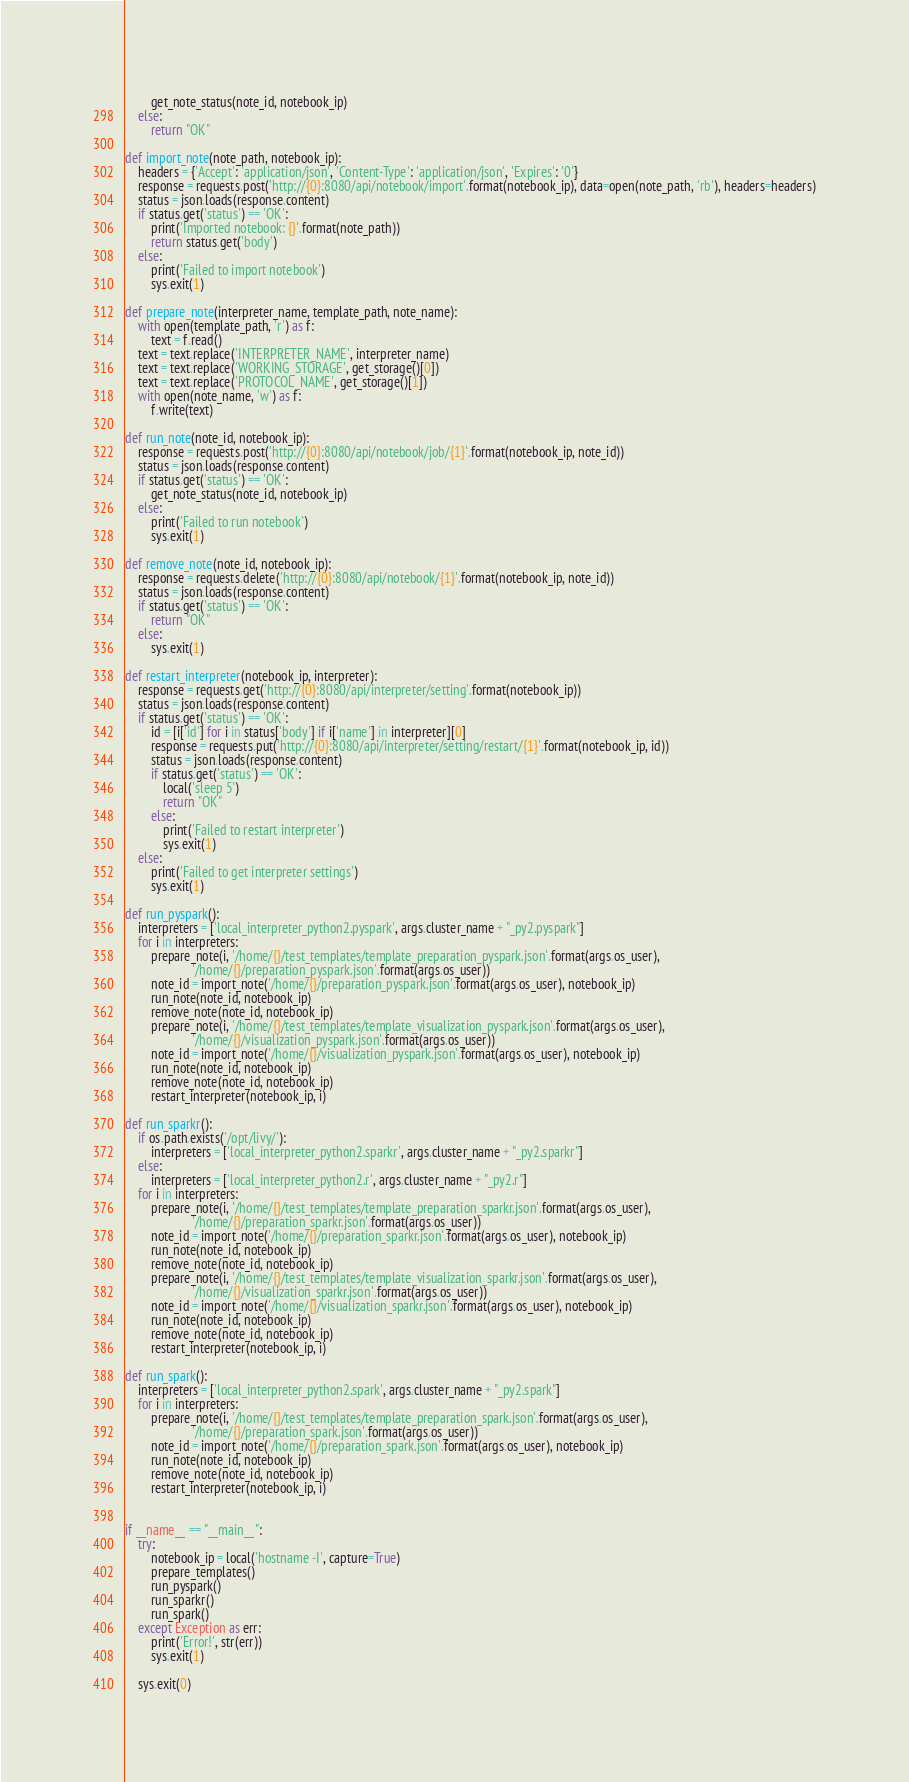Convert code to text. <code><loc_0><loc_0><loc_500><loc_500><_Python_>        get_note_status(note_id, notebook_ip)
    else:
        return "OK"

def import_note(note_path, notebook_ip):
    headers = {'Accept': 'application/json', 'Content-Type': 'application/json', 'Expires': '0'}
    response = requests.post('http://{0}:8080/api/notebook/import'.format(notebook_ip), data=open(note_path, 'rb'), headers=headers)
    status = json.loads(response.content)
    if status.get('status') == 'OK':
        print('Imported notebook: {}'.format(note_path))
        return status.get('body')
    else:
        print('Failed to import notebook')
        sys.exit(1)

def prepare_note(interpreter_name, template_path, note_name):
    with open(template_path, 'r') as f:
        text = f.read()
    text = text.replace('INTERPRETER_NAME', interpreter_name)
    text = text.replace('WORKING_STORAGE', get_storage()[0])
    text = text.replace('PROTOCOL_NAME', get_storage()[1])
    with open(note_name, 'w') as f:
        f.write(text)

def run_note(note_id, notebook_ip):
    response = requests.post('http://{0}:8080/api/notebook/job/{1}'.format(notebook_ip, note_id))
    status = json.loads(response.content)
    if status.get('status') == 'OK':
        get_note_status(note_id, notebook_ip)
    else:
        print('Failed to run notebook')
        sys.exit(1)

def remove_note(note_id, notebook_ip):
    response = requests.delete('http://{0}:8080/api/notebook/{1}'.format(notebook_ip, note_id))
    status = json.loads(response.content)
    if status.get('status') == 'OK':
        return "OK"
    else:
        sys.exit(1)

def restart_interpreter(notebook_ip, interpreter):
    response = requests.get('http://{0}:8080/api/interpreter/setting'.format(notebook_ip))
    status = json.loads(response.content)
    if status.get('status') == 'OK':
        id = [i['id'] for i in status['body'] if i['name'] in interpreter][0]
        response = requests.put('http://{0}:8080/api/interpreter/setting/restart/{1}'.format(notebook_ip, id))
        status = json.loads(response.content)
        if status.get('status') == 'OK':
            local('sleep 5')
            return "OK"
        else:
            print('Failed to restart interpreter')
            sys.exit(1)
    else:
        print('Failed to get interpreter settings')
        sys.exit(1)

def run_pyspark():
    interpreters = ['local_interpreter_python2.pyspark', args.cluster_name + "_py2.pyspark"]
    for i in interpreters:
        prepare_note(i, '/home/{}/test_templates/template_preparation_pyspark.json'.format(args.os_user),
                     '/home/{}/preparation_pyspark.json'.format(args.os_user))
        note_id = import_note('/home/{}/preparation_pyspark.json'.format(args.os_user), notebook_ip)
        run_note(note_id, notebook_ip)
        remove_note(note_id, notebook_ip)
        prepare_note(i, '/home/{}/test_templates/template_visualization_pyspark.json'.format(args.os_user),
                     '/home/{}/visualization_pyspark.json'.format(args.os_user))
        note_id = import_note('/home/{}/visualization_pyspark.json'.format(args.os_user), notebook_ip)
        run_note(note_id, notebook_ip)
        remove_note(note_id, notebook_ip)
        restart_interpreter(notebook_ip, i)

def run_sparkr():
    if os.path.exists('/opt/livy/'):
        interpreters = ['local_interpreter_python2.sparkr', args.cluster_name + "_py2.sparkr"]
    else:
        interpreters = ['local_interpreter_python2.r', args.cluster_name + "_py2.r"]
    for i in interpreters:
        prepare_note(i, '/home/{}/test_templates/template_preparation_sparkr.json'.format(args.os_user),
                     '/home/{}/preparation_sparkr.json'.format(args.os_user))
        note_id = import_note('/home/{}/preparation_sparkr.json'.format(args.os_user), notebook_ip)
        run_note(note_id, notebook_ip)
        remove_note(note_id, notebook_ip)
        prepare_note(i, '/home/{}/test_templates/template_visualization_sparkr.json'.format(args.os_user),
                     '/home/{}/visualization_sparkr.json'.format(args.os_user))
        note_id = import_note('/home/{}/visualization_sparkr.json'.format(args.os_user), notebook_ip)
        run_note(note_id, notebook_ip)
        remove_note(note_id, notebook_ip)
        restart_interpreter(notebook_ip, i)

def run_spark():
    interpreters = ['local_interpreter_python2.spark', args.cluster_name + "_py2.spark"]
    for i in interpreters:
        prepare_note(i, '/home/{}/test_templates/template_preparation_spark.json'.format(args.os_user),
                     '/home/{}/preparation_spark.json'.format(args.os_user))
        note_id = import_note('/home/{}/preparation_spark.json'.format(args.os_user), notebook_ip)
        run_note(note_id, notebook_ip)
        remove_note(note_id, notebook_ip)
        restart_interpreter(notebook_ip, i)


if __name__ == "__main__":
    try:
        notebook_ip = local('hostname -I', capture=True)
        prepare_templates()
        run_pyspark()
        run_sparkr()
        run_spark()
    except Exception as err:
        print('Error!', str(err))
        sys.exit(1)

    sys.exit(0)</code> 